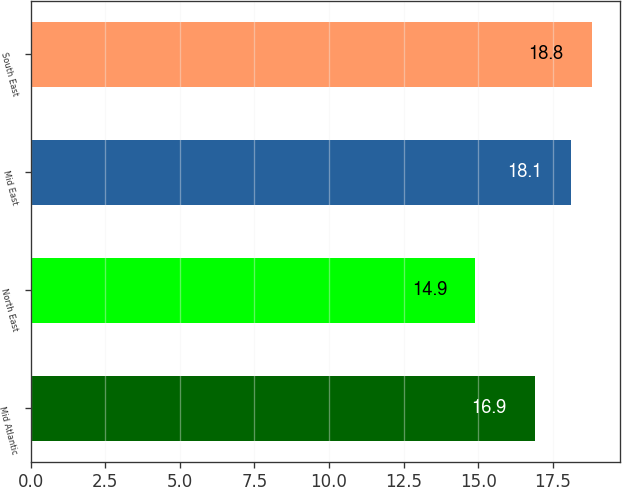Convert chart to OTSL. <chart><loc_0><loc_0><loc_500><loc_500><bar_chart><fcel>Mid Atlantic<fcel>North East<fcel>Mid East<fcel>South East<nl><fcel>16.9<fcel>14.9<fcel>18.1<fcel>18.8<nl></chart> 